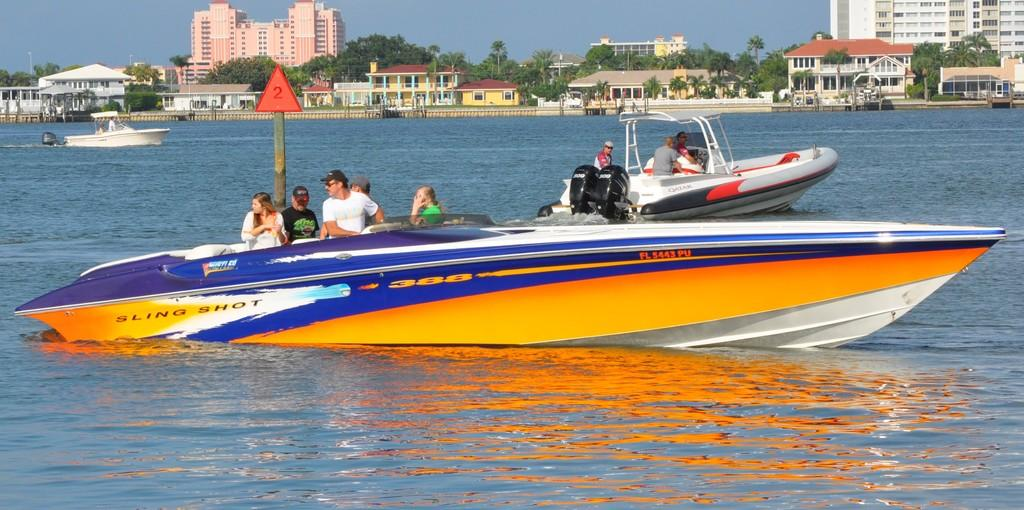What activity are the people in the image engaged in? The people in the image are sailing boats. Where are the boats located? The boats are on the water. What can be seen on the pole in the image? There is a pole with a sign board in the image. What type of structures are visible in the image? There are buildings and houses visible in the image. What type of vegetation is present in the image? Trees are present in the image. What part of the natural environment is visible in the image? The sky is visible in the image. What type of noise can be heard coming from the creator in the image? There is no creator present in the image, and therefore no such noise can be heard. 